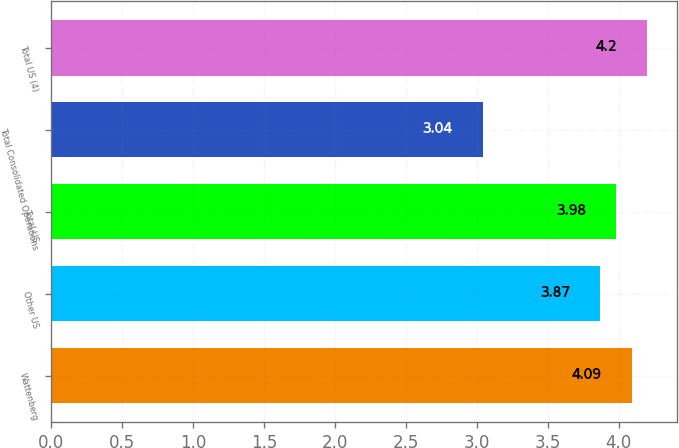<chart> <loc_0><loc_0><loc_500><loc_500><bar_chart><fcel>Wattenberg<fcel>Other US<fcel>Total US<fcel>Total Consolidated Operations<fcel>Total US (4)<nl><fcel>4.09<fcel>3.87<fcel>3.98<fcel>3.04<fcel>4.2<nl></chart> 